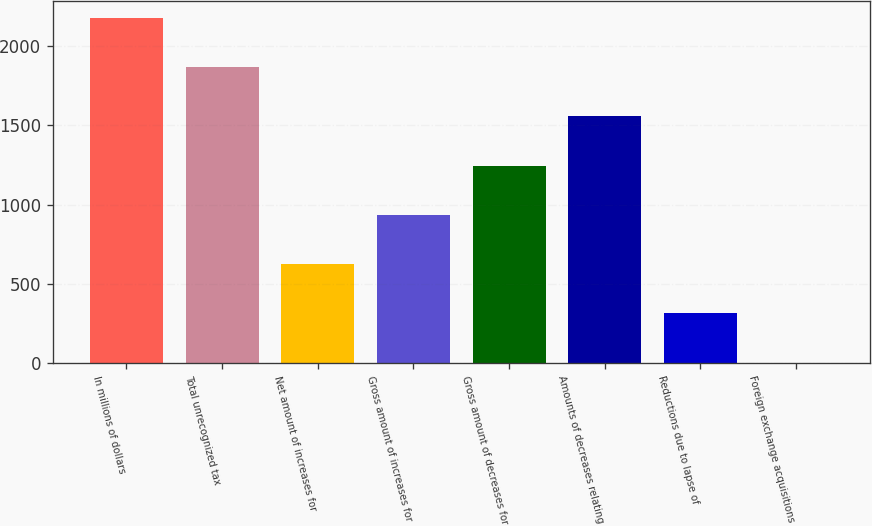<chart> <loc_0><loc_0><loc_500><loc_500><bar_chart><fcel>In millions of dollars<fcel>Total unrecognized tax<fcel>Net amount of increases for<fcel>Gross amount of increases for<fcel>Gross amount of decreases for<fcel>Amounts of decreases relating<fcel>Reductions due to lapse of<fcel>Foreign exchange acquisitions<nl><fcel>2176.9<fcel>1866.2<fcel>623.4<fcel>934.1<fcel>1244.8<fcel>1555.5<fcel>312.7<fcel>2<nl></chart> 